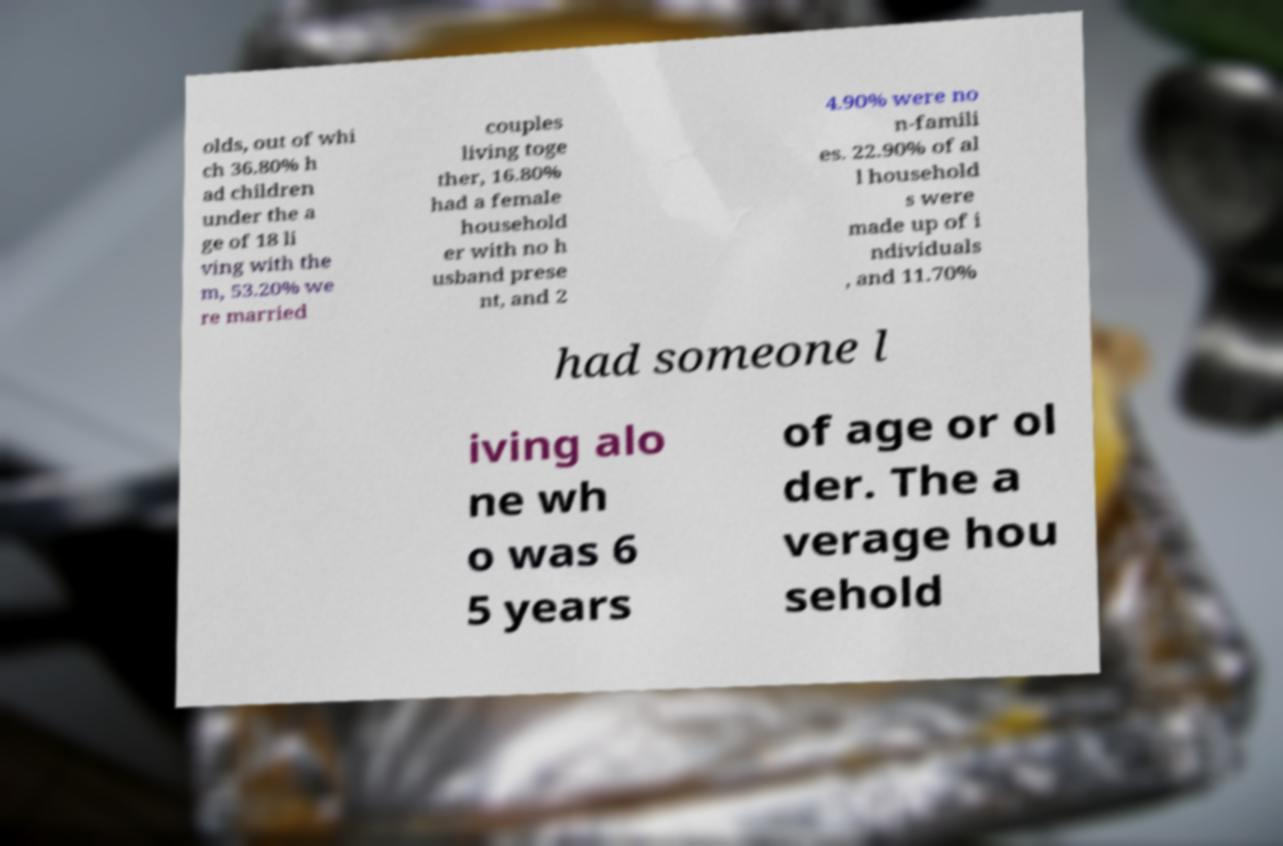There's text embedded in this image that I need extracted. Can you transcribe it verbatim? olds, out of whi ch 36.80% h ad children under the a ge of 18 li ving with the m, 53.20% we re married couples living toge ther, 16.80% had a female household er with no h usband prese nt, and 2 4.90% were no n-famili es. 22.90% of al l household s were made up of i ndividuals , and 11.70% had someone l iving alo ne wh o was 6 5 years of age or ol der. The a verage hou sehold 